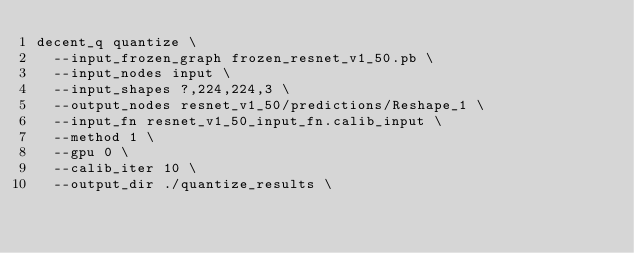<code> <loc_0><loc_0><loc_500><loc_500><_Bash_>decent_q quantize \
  --input_frozen_graph frozen_resnet_v1_50.pb \
  --input_nodes input \
  --input_shapes ?,224,224,3 \
  --output_nodes resnet_v1_50/predictions/Reshape_1 \
  --input_fn resnet_v1_50_input_fn.calib_input \
  --method 1 \
  --gpu 0 \
  --calib_iter 10 \
  --output_dir ./quantize_results \
</code> 